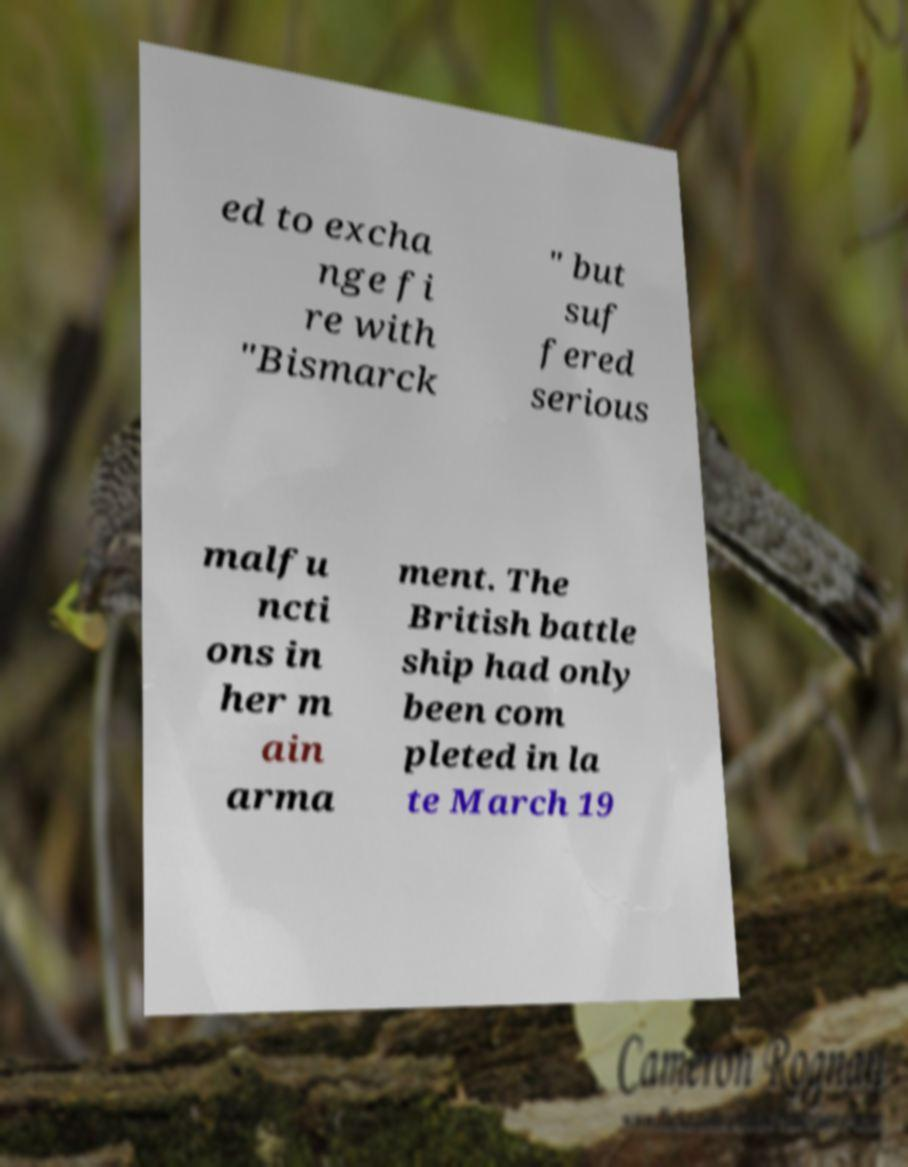For documentation purposes, I need the text within this image transcribed. Could you provide that? ed to excha nge fi re with "Bismarck " but suf fered serious malfu ncti ons in her m ain arma ment. The British battle ship had only been com pleted in la te March 19 